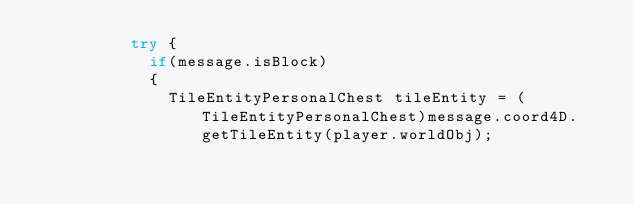Convert code to text. <code><loc_0><loc_0><loc_500><loc_500><_Java_>					try {
						if(message.isBlock)
						{
							TileEntityPersonalChest tileEntity = (TileEntityPersonalChest)message.coord4D.getTileEntity(player.worldObj);</code> 